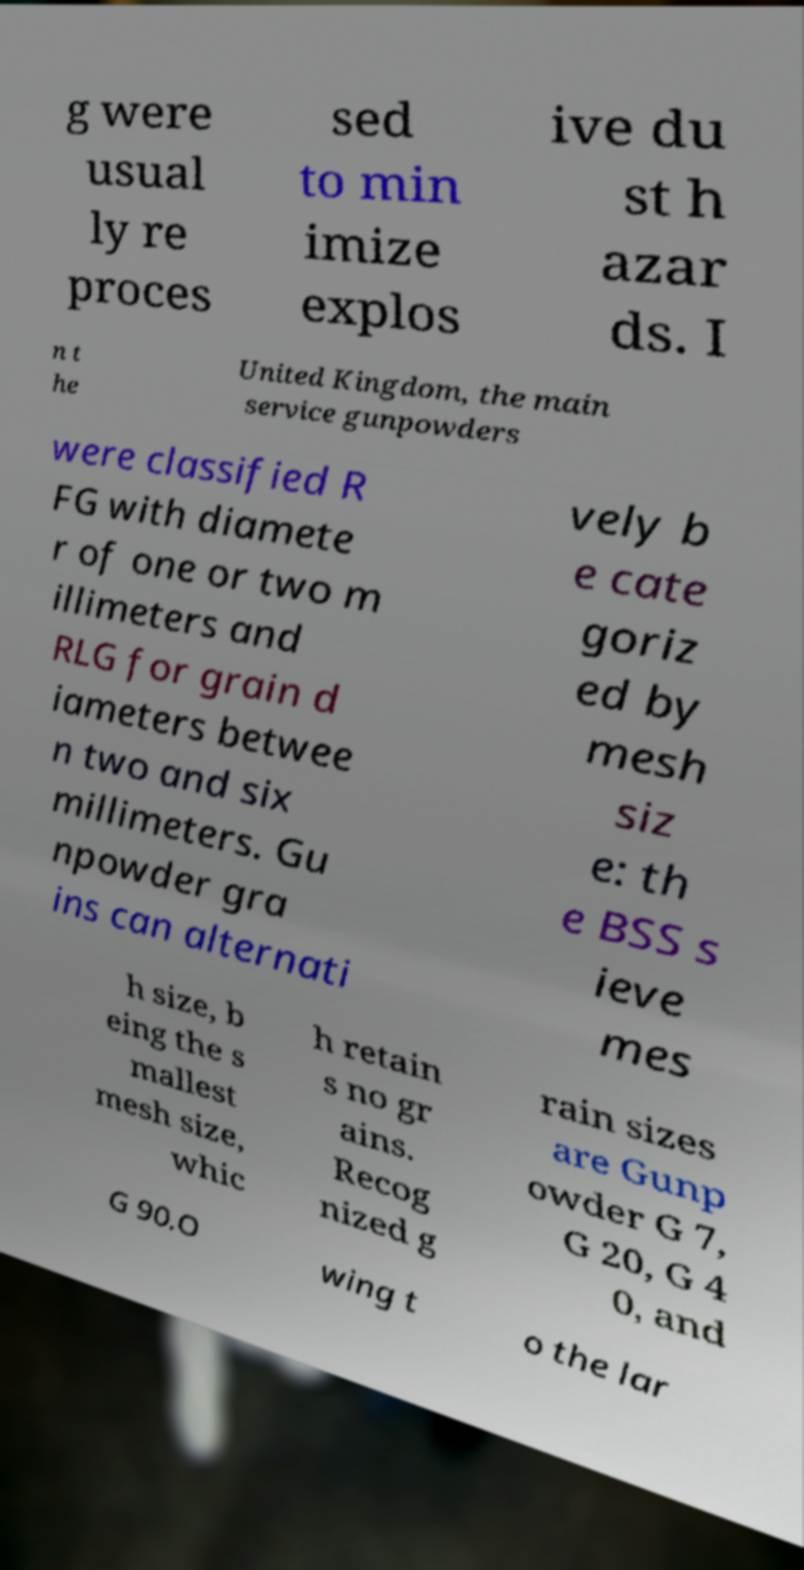Can you accurately transcribe the text from the provided image for me? g were usual ly re proces sed to min imize explos ive du st h azar ds. I n t he United Kingdom, the main service gunpowders were classified R FG with diamete r of one or two m illimeters and RLG for grain d iameters betwee n two and six millimeters. Gu npowder gra ins can alternati vely b e cate goriz ed by mesh siz e: th e BSS s ieve mes h size, b eing the s mallest mesh size, whic h retain s no gr ains. Recog nized g rain sizes are Gunp owder G 7, G 20, G 4 0, and G 90.O wing t o the lar 